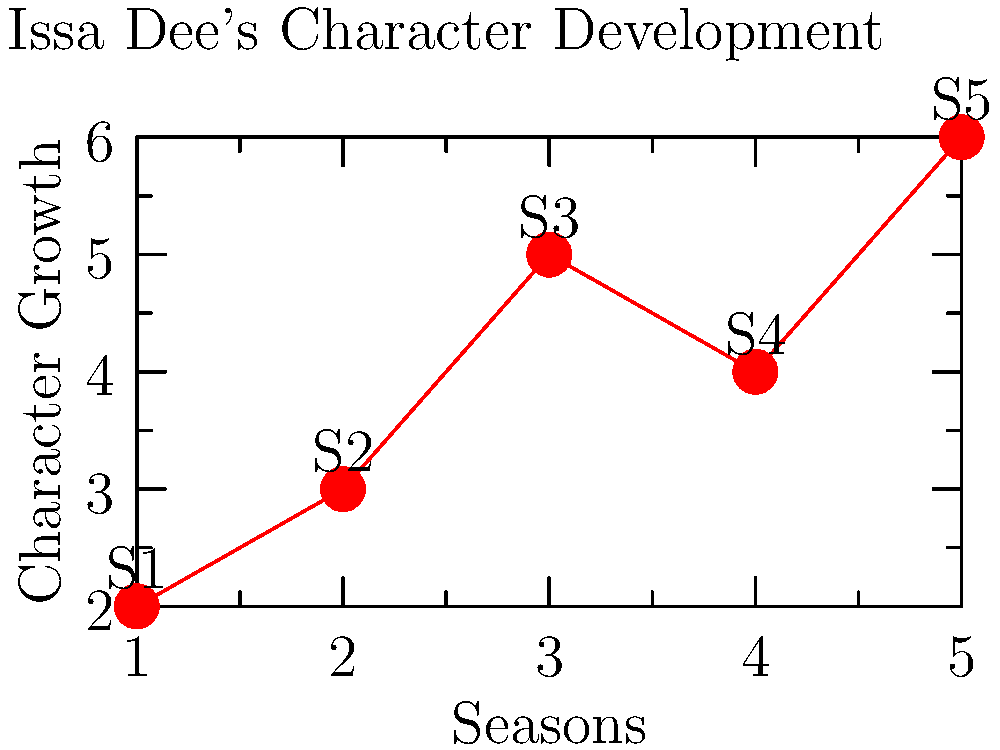Based on the line graph depicting Issa Dee's character development across the five seasons of "Insecure," which season marks the most significant growth in her character arc, and what might this suggest about the narrative structure of the show? To answer this question, we need to analyze the line graph step-by-step:

1. The x-axis represents the seasons (S1 to S5) of "Insecure."
2. The y-axis represents Issa Dee's character growth.
3. We can see the following progression:
   - S1 to S2: Moderate growth
   - S2 to S3: Steep increase in growth
   - S3 to S4: Slight decline
   - S4 to S5: Sharp increase, reaching the highest point

4. The most significant growth occurs between S2 and S3, as indicated by the steepest line segment on the graph.

5. This significant growth in Season 3 suggests:
   - A turning point in Issa's character development
   - Possibly major life events or decisions that catalyze her growth
   - A potential midpoint in the overall series arc, as it's the central season

6. The slight decline in S4 followed by the sharp increase in S5 implies:
   - A narrative technique of creating tension or setbacks before the final resolution
   - A build-up to a strong series finale where Issa reaches her peak character development

This pattern aligns with classic storytelling structures, where the middle of the narrative often contains significant character growth, followed by challenges, and culminating in a final period of growth and resolution.
Answer: Season 3; midpoint character transformation and classic narrative structure 